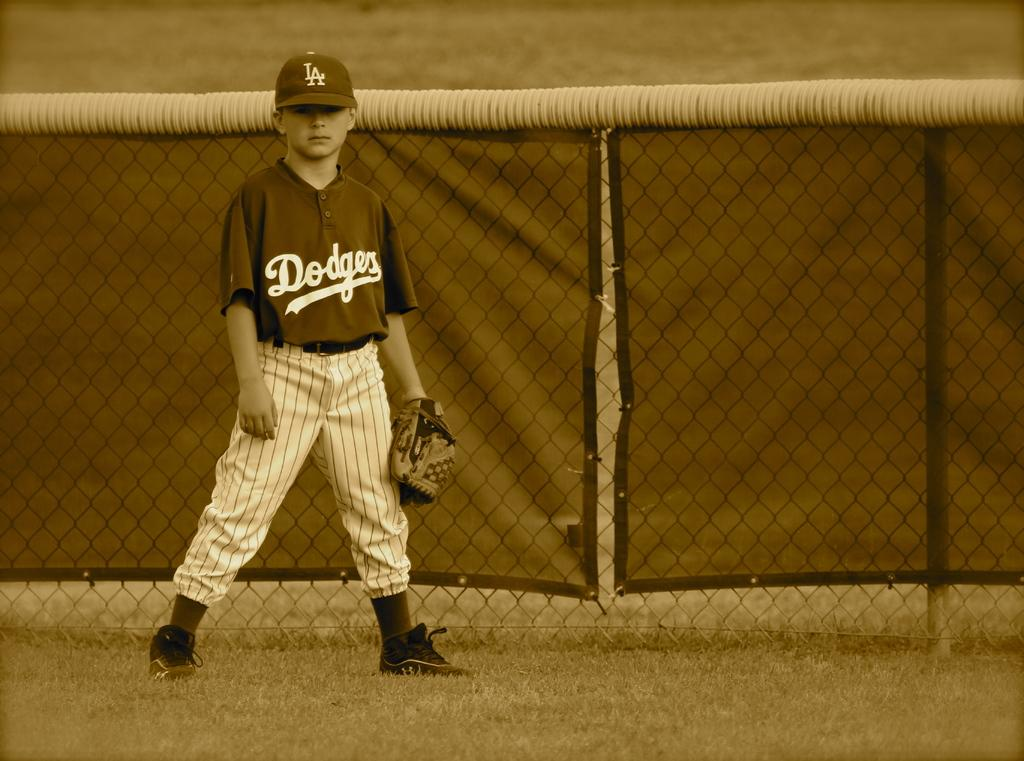Provide a one-sentence caption for the provided image. A little boy in a baseball uniform that has LA Dodgers on it. 